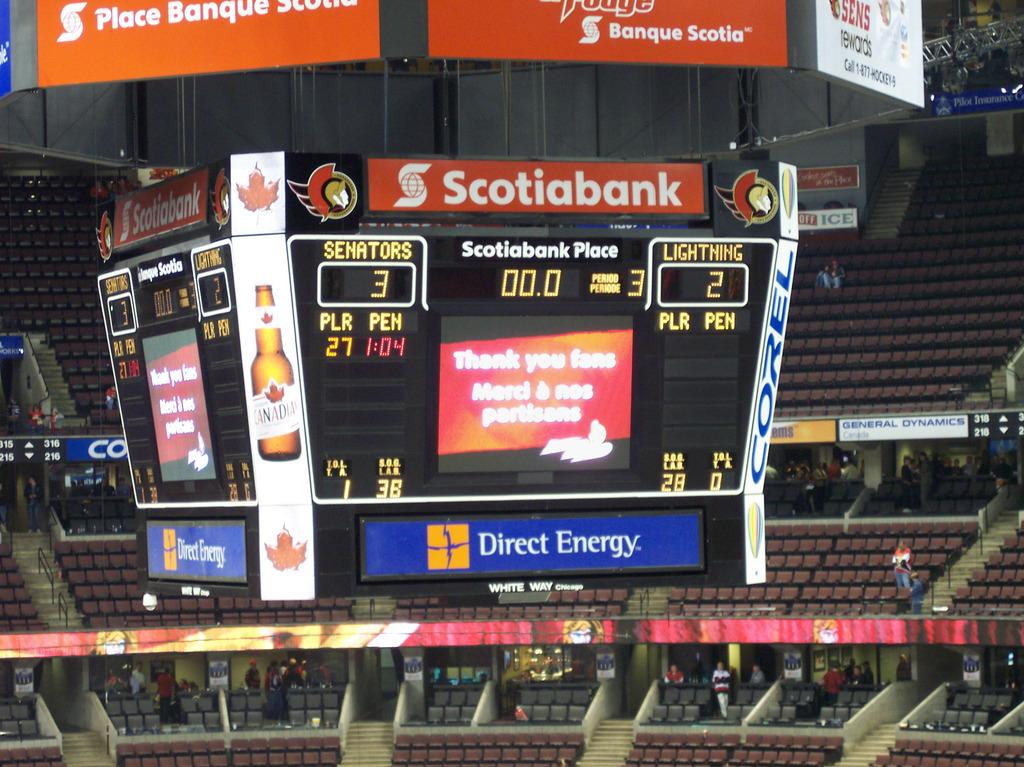<image>
Render a clear and concise summary of the photo. An electronic board which has Scotiabank as one of its sponsors. 